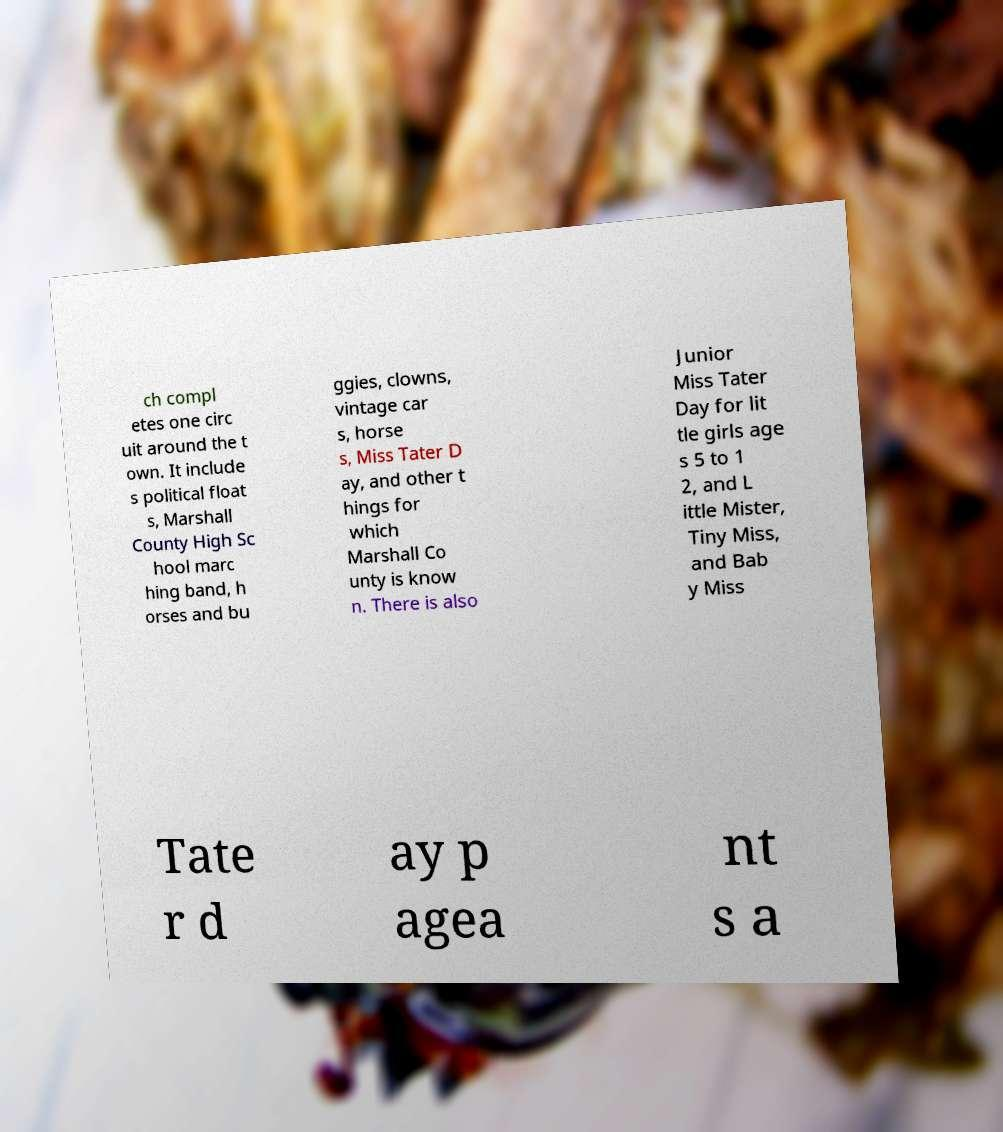For documentation purposes, I need the text within this image transcribed. Could you provide that? ch compl etes one circ uit around the t own. It include s political float s, Marshall County High Sc hool marc hing band, h orses and bu ggies, clowns, vintage car s, horse s, Miss Tater D ay, and other t hings for which Marshall Co unty is know n. There is also Junior Miss Tater Day for lit tle girls age s 5 to 1 2, and L ittle Mister, Tiny Miss, and Bab y Miss Tate r d ay p agea nt s a 